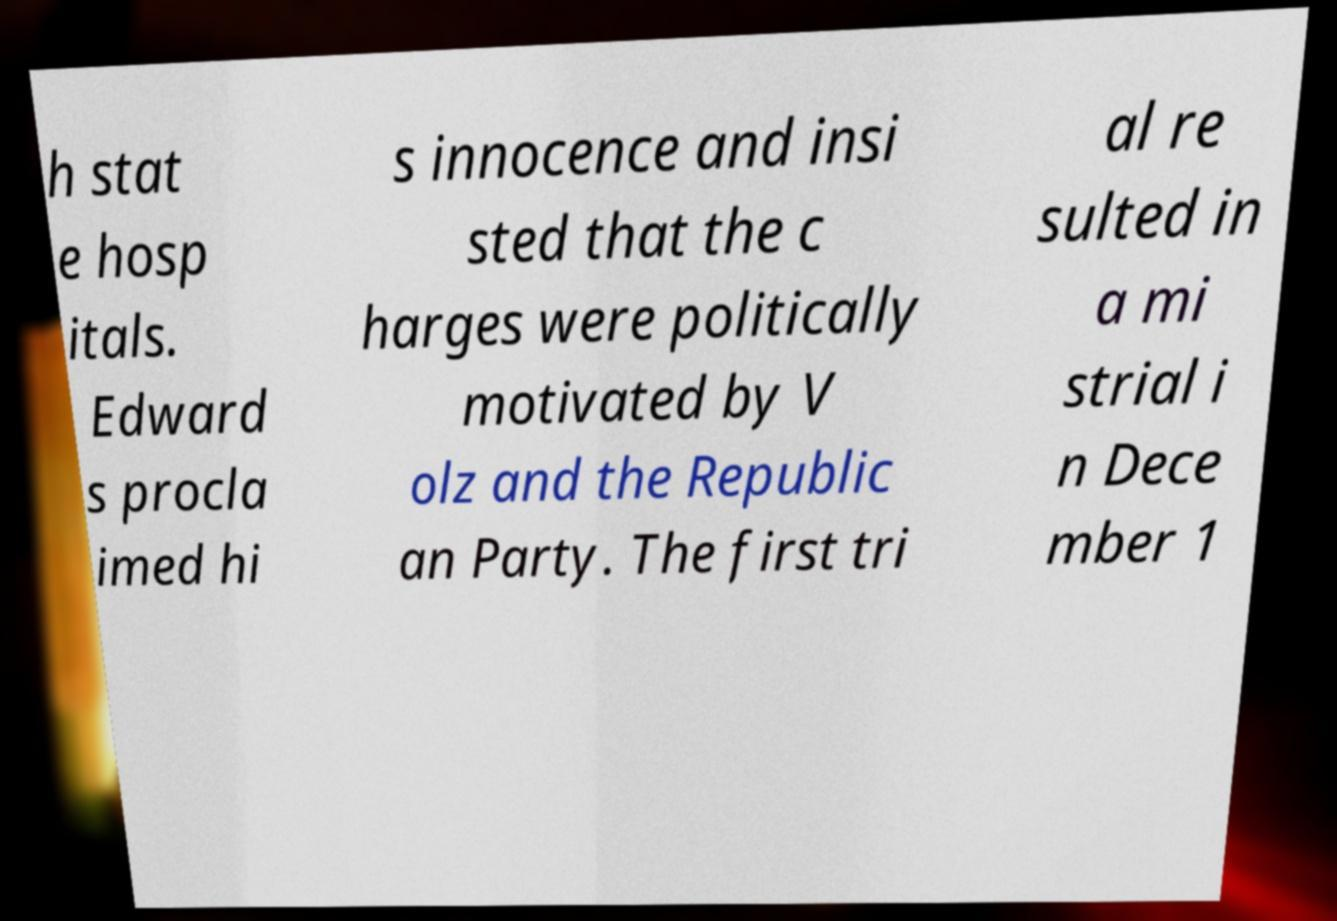Could you assist in decoding the text presented in this image and type it out clearly? h stat e hosp itals. Edward s procla imed hi s innocence and insi sted that the c harges were politically motivated by V olz and the Republic an Party. The first tri al re sulted in a mi strial i n Dece mber 1 